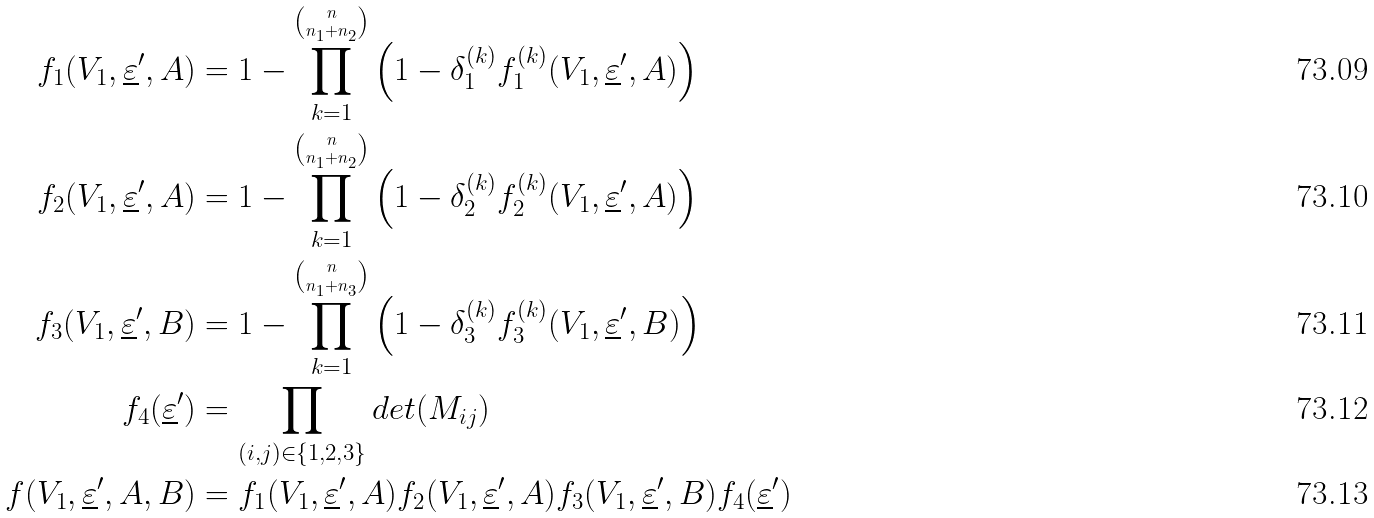<formula> <loc_0><loc_0><loc_500><loc_500>f _ { 1 } ( V _ { 1 } , \underline { \varepsilon } ^ { \prime } , A ) & = 1 - \prod _ { k = 1 } ^ { n \choose n _ { 1 } + n _ { 2 } } \left ( 1 - \delta _ { 1 } ^ { ( k ) } f ^ { ( k ) } _ { 1 } ( V _ { 1 } , \underline { \varepsilon } ^ { \prime } , A ) \right ) \\ f _ { 2 } ( V _ { 1 } , \underline { \varepsilon } ^ { \prime } , A ) & = 1 - \prod _ { k = 1 } ^ { n \choose n _ { 1 } + n _ { 2 } } \left ( 1 - \delta _ { 2 } ^ { ( k ) } f ^ { ( k ) } _ { 2 } ( V _ { 1 } , \underline { \varepsilon } ^ { \prime } , A ) \right ) \\ f _ { 3 } ( V _ { 1 } , \underline { \varepsilon } ^ { \prime } , B ) & = 1 - \prod _ { k = 1 } ^ { n \choose n _ { 1 } + n _ { 3 } } \left ( 1 - \delta _ { 3 } ^ { ( k ) } f ^ { ( k ) } _ { 3 } ( V _ { 1 } , \underline { \varepsilon } ^ { \prime } , B ) \right ) \\ f _ { 4 } ( \underline { \varepsilon } ^ { \prime } ) & = \prod _ { ( i , j ) \in \{ 1 , 2 , 3 \} } d e t ( M _ { i j } ) \\ f ( V _ { 1 } , \underline { \varepsilon } ^ { \prime } , A , B ) & = f _ { 1 } ( V _ { 1 } , \underline { \varepsilon } ^ { \prime } , A ) f _ { 2 } ( V _ { 1 } , \underline { \varepsilon } ^ { \prime } , A ) f _ { 3 } ( V _ { 1 } , \underline { \varepsilon } ^ { \prime } , B ) f _ { 4 } ( \underline { \varepsilon } ^ { \prime } )</formula> 